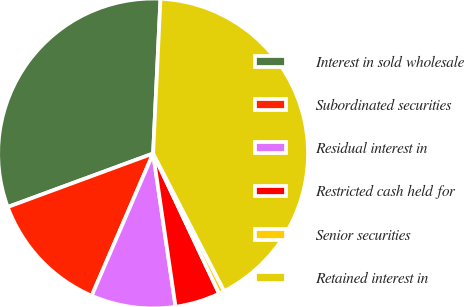Convert chart to OTSL. <chart><loc_0><loc_0><loc_500><loc_500><pie_chart><fcel>Interest in sold wholesale<fcel>Subordinated securities<fcel>Residual interest in<fcel>Restricted cash held for<fcel>Senior securities<fcel>Retained interest in<nl><fcel>31.37%<fcel>12.9%<fcel>8.8%<fcel>4.69%<fcel>0.58%<fcel>41.65%<nl></chart> 